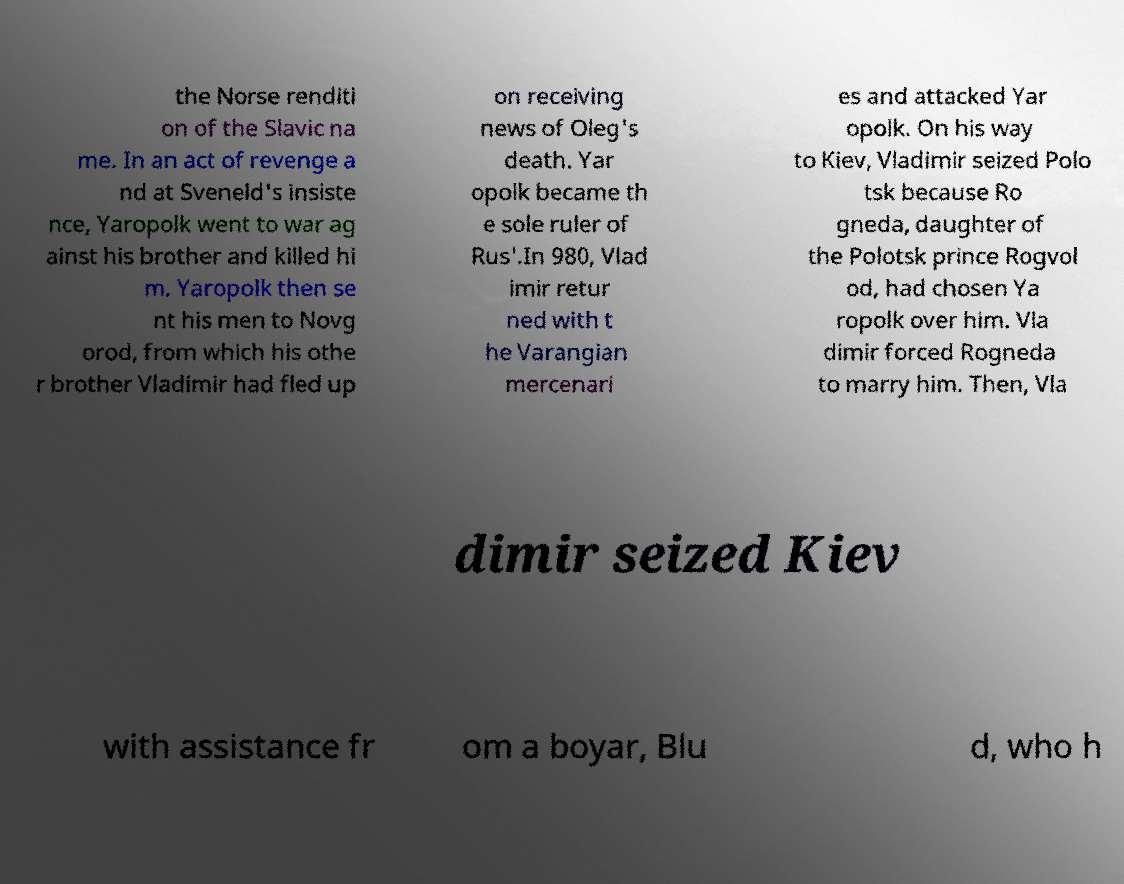Can you read and provide the text displayed in the image?This photo seems to have some interesting text. Can you extract and type it out for me? the Norse renditi on of the Slavic na me. In an act of revenge a nd at Sveneld's insiste nce, Yaropolk went to war ag ainst his brother and killed hi m. Yaropolk then se nt his men to Novg orod, from which his othe r brother Vladimir had fled up on receiving news of Oleg's death. Yar opolk became th e sole ruler of Rus'.In 980, Vlad imir retur ned with t he Varangian mercenari es and attacked Yar opolk. On his way to Kiev, Vladimir seized Polo tsk because Ro gneda, daughter of the Polotsk prince Rogvol od, had chosen Ya ropolk over him. Vla dimir forced Rogneda to marry him. Then, Vla dimir seized Kiev with assistance fr om a boyar, Blu d, who h 